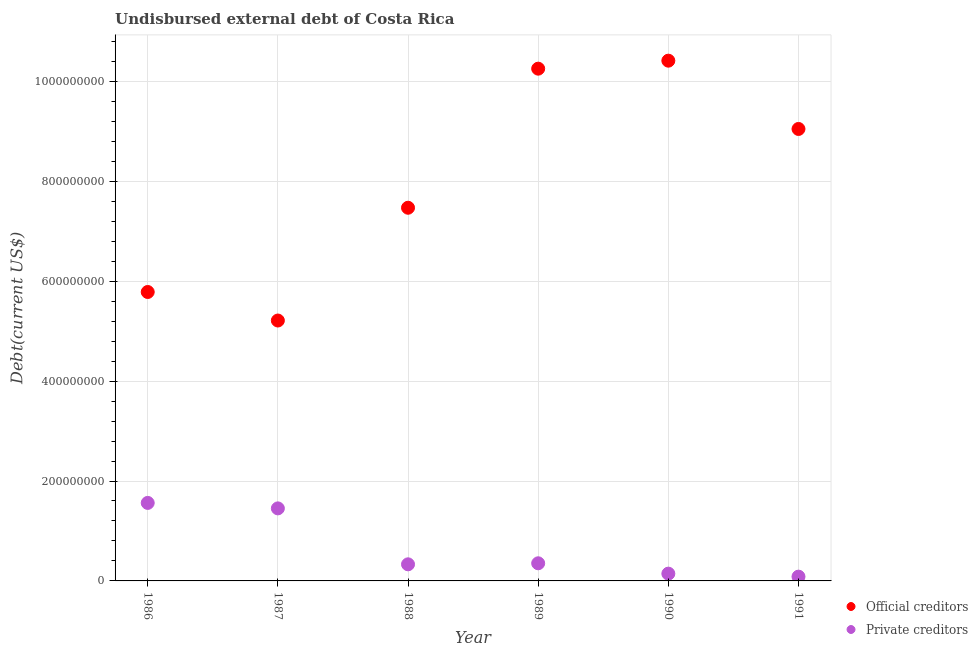What is the undisbursed external debt of private creditors in 1990?
Offer a very short reply. 1.46e+07. Across all years, what is the maximum undisbursed external debt of private creditors?
Make the answer very short. 1.56e+08. Across all years, what is the minimum undisbursed external debt of official creditors?
Ensure brevity in your answer.  5.21e+08. In which year was the undisbursed external debt of official creditors maximum?
Provide a succinct answer. 1990. In which year was the undisbursed external debt of private creditors minimum?
Offer a terse response. 1991. What is the total undisbursed external debt of official creditors in the graph?
Provide a succinct answer. 4.82e+09. What is the difference between the undisbursed external debt of official creditors in 1986 and that in 1987?
Your response must be concise. 5.71e+07. What is the difference between the undisbursed external debt of official creditors in 1990 and the undisbursed external debt of private creditors in 1988?
Provide a short and direct response. 1.01e+09. What is the average undisbursed external debt of private creditors per year?
Give a very brief answer. 6.55e+07. In the year 1989, what is the difference between the undisbursed external debt of private creditors and undisbursed external debt of official creditors?
Your answer should be compact. -9.90e+08. What is the ratio of the undisbursed external debt of private creditors in 1986 to that in 1991?
Provide a succinct answer. 18.25. Is the undisbursed external debt of official creditors in 1986 less than that in 1991?
Provide a short and direct response. Yes. Is the difference between the undisbursed external debt of official creditors in 1989 and 1991 greater than the difference between the undisbursed external debt of private creditors in 1989 and 1991?
Offer a very short reply. Yes. What is the difference between the highest and the second highest undisbursed external debt of official creditors?
Offer a terse response. 1.60e+07. What is the difference between the highest and the lowest undisbursed external debt of official creditors?
Offer a very short reply. 5.20e+08. Is the sum of the undisbursed external debt of official creditors in 1988 and 1990 greater than the maximum undisbursed external debt of private creditors across all years?
Your answer should be compact. Yes. Does the graph contain grids?
Keep it short and to the point. Yes. Where does the legend appear in the graph?
Offer a very short reply. Bottom right. How many legend labels are there?
Provide a succinct answer. 2. What is the title of the graph?
Ensure brevity in your answer.  Undisbursed external debt of Costa Rica. Does "Primary completion rate" appear as one of the legend labels in the graph?
Your response must be concise. No. What is the label or title of the X-axis?
Offer a very short reply. Year. What is the label or title of the Y-axis?
Your response must be concise. Debt(current US$). What is the Debt(current US$) in Official creditors in 1986?
Provide a short and direct response. 5.78e+08. What is the Debt(current US$) in Private creditors in 1986?
Provide a succinct answer. 1.56e+08. What is the Debt(current US$) of Official creditors in 1987?
Your response must be concise. 5.21e+08. What is the Debt(current US$) of Private creditors in 1987?
Offer a very short reply. 1.45e+08. What is the Debt(current US$) of Official creditors in 1988?
Your answer should be compact. 7.47e+08. What is the Debt(current US$) of Private creditors in 1988?
Ensure brevity in your answer.  3.32e+07. What is the Debt(current US$) in Official creditors in 1989?
Your response must be concise. 1.03e+09. What is the Debt(current US$) in Private creditors in 1989?
Keep it short and to the point. 3.53e+07. What is the Debt(current US$) of Official creditors in 1990?
Offer a terse response. 1.04e+09. What is the Debt(current US$) in Private creditors in 1990?
Ensure brevity in your answer.  1.46e+07. What is the Debt(current US$) of Official creditors in 1991?
Make the answer very short. 9.05e+08. What is the Debt(current US$) of Private creditors in 1991?
Ensure brevity in your answer.  8.56e+06. Across all years, what is the maximum Debt(current US$) of Official creditors?
Provide a short and direct response. 1.04e+09. Across all years, what is the maximum Debt(current US$) in Private creditors?
Provide a succinct answer. 1.56e+08. Across all years, what is the minimum Debt(current US$) in Official creditors?
Your response must be concise. 5.21e+08. Across all years, what is the minimum Debt(current US$) of Private creditors?
Your answer should be very brief. 8.56e+06. What is the total Debt(current US$) in Official creditors in the graph?
Your answer should be compact. 4.82e+09. What is the total Debt(current US$) in Private creditors in the graph?
Your answer should be compact. 3.93e+08. What is the difference between the Debt(current US$) in Official creditors in 1986 and that in 1987?
Ensure brevity in your answer.  5.71e+07. What is the difference between the Debt(current US$) of Private creditors in 1986 and that in 1987?
Your answer should be compact. 1.10e+07. What is the difference between the Debt(current US$) in Official creditors in 1986 and that in 1988?
Provide a short and direct response. -1.69e+08. What is the difference between the Debt(current US$) of Private creditors in 1986 and that in 1988?
Your answer should be very brief. 1.23e+08. What is the difference between the Debt(current US$) of Official creditors in 1986 and that in 1989?
Offer a terse response. -4.47e+08. What is the difference between the Debt(current US$) in Private creditors in 1986 and that in 1989?
Give a very brief answer. 1.21e+08. What is the difference between the Debt(current US$) in Official creditors in 1986 and that in 1990?
Your answer should be compact. -4.63e+08. What is the difference between the Debt(current US$) in Private creditors in 1986 and that in 1990?
Provide a succinct answer. 1.42e+08. What is the difference between the Debt(current US$) of Official creditors in 1986 and that in 1991?
Provide a short and direct response. -3.26e+08. What is the difference between the Debt(current US$) in Private creditors in 1986 and that in 1991?
Ensure brevity in your answer.  1.48e+08. What is the difference between the Debt(current US$) of Official creditors in 1987 and that in 1988?
Give a very brief answer. -2.26e+08. What is the difference between the Debt(current US$) of Private creditors in 1987 and that in 1988?
Give a very brief answer. 1.12e+08. What is the difference between the Debt(current US$) in Official creditors in 1987 and that in 1989?
Provide a succinct answer. -5.04e+08. What is the difference between the Debt(current US$) of Private creditors in 1987 and that in 1989?
Your answer should be very brief. 1.10e+08. What is the difference between the Debt(current US$) in Official creditors in 1987 and that in 1990?
Keep it short and to the point. -5.20e+08. What is the difference between the Debt(current US$) in Private creditors in 1987 and that in 1990?
Your answer should be compact. 1.31e+08. What is the difference between the Debt(current US$) in Official creditors in 1987 and that in 1991?
Your answer should be compact. -3.83e+08. What is the difference between the Debt(current US$) of Private creditors in 1987 and that in 1991?
Provide a succinct answer. 1.37e+08. What is the difference between the Debt(current US$) of Official creditors in 1988 and that in 1989?
Keep it short and to the point. -2.78e+08. What is the difference between the Debt(current US$) in Private creditors in 1988 and that in 1989?
Your answer should be very brief. -2.06e+06. What is the difference between the Debt(current US$) in Official creditors in 1988 and that in 1990?
Make the answer very short. -2.94e+08. What is the difference between the Debt(current US$) of Private creditors in 1988 and that in 1990?
Give a very brief answer. 1.87e+07. What is the difference between the Debt(current US$) of Official creditors in 1988 and that in 1991?
Offer a terse response. -1.58e+08. What is the difference between the Debt(current US$) of Private creditors in 1988 and that in 1991?
Provide a short and direct response. 2.47e+07. What is the difference between the Debt(current US$) in Official creditors in 1989 and that in 1990?
Your response must be concise. -1.60e+07. What is the difference between the Debt(current US$) in Private creditors in 1989 and that in 1990?
Make the answer very short. 2.07e+07. What is the difference between the Debt(current US$) in Official creditors in 1989 and that in 1991?
Your answer should be very brief. 1.21e+08. What is the difference between the Debt(current US$) in Private creditors in 1989 and that in 1991?
Offer a terse response. 2.67e+07. What is the difference between the Debt(current US$) of Official creditors in 1990 and that in 1991?
Provide a short and direct response. 1.37e+08. What is the difference between the Debt(current US$) in Private creditors in 1990 and that in 1991?
Offer a terse response. 6.01e+06. What is the difference between the Debt(current US$) of Official creditors in 1986 and the Debt(current US$) of Private creditors in 1987?
Offer a terse response. 4.33e+08. What is the difference between the Debt(current US$) in Official creditors in 1986 and the Debt(current US$) in Private creditors in 1988?
Your answer should be very brief. 5.45e+08. What is the difference between the Debt(current US$) in Official creditors in 1986 and the Debt(current US$) in Private creditors in 1989?
Give a very brief answer. 5.43e+08. What is the difference between the Debt(current US$) in Official creditors in 1986 and the Debt(current US$) in Private creditors in 1990?
Ensure brevity in your answer.  5.64e+08. What is the difference between the Debt(current US$) in Official creditors in 1986 and the Debt(current US$) in Private creditors in 1991?
Your answer should be compact. 5.70e+08. What is the difference between the Debt(current US$) of Official creditors in 1987 and the Debt(current US$) of Private creditors in 1988?
Offer a terse response. 4.88e+08. What is the difference between the Debt(current US$) of Official creditors in 1987 and the Debt(current US$) of Private creditors in 1989?
Your answer should be very brief. 4.86e+08. What is the difference between the Debt(current US$) of Official creditors in 1987 and the Debt(current US$) of Private creditors in 1990?
Keep it short and to the point. 5.07e+08. What is the difference between the Debt(current US$) of Official creditors in 1987 and the Debt(current US$) of Private creditors in 1991?
Give a very brief answer. 5.13e+08. What is the difference between the Debt(current US$) in Official creditors in 1988 and the Debt(current US$) in Private creditors in 1989?
Ensure brevity in your answer.  7.12e+08. What is the difference between the Debt(current US$) in Official creditors in 1988 and the Debt(current US$) in Private creditors in 1990?
Keep it short and to the point. 7.32e+08. What is the difference between the Debt(current US$) of Official creditors in 1988 and the Debt(current US$) of Private creditors in 1991?
Provide a succinct answer. 7.38e+08. What is the difference between the Debt(current US$) in Official creditors in 1989 and the Debt(current US$) in Private creditors in 1990?
Your answer should be compact. 1.01e+09. What is the difference between the Debt(current US$) of Official creditors in 1989 and the Debt(current US$) of Private creditors in 1991?
Your answer should be compact. 1.02e+09. What is the difference between the Debt(current US$) in Official creditors in 1990 and the Debt(current US$) in Private creditors in 1991?
Provide a succinct answer. 1.03e+09. What is the average Debt(current US$) in Official creditors per year?
Make the answer very short. 8.03e+08. What is the average Debt(current US$) in Private creditors per year?
Keep it short and to the point. 6.55e+07. In the year 1986, what is the difference between the Debt(current US$) in Official creditors and Debt(current US$) in Private creditors?
Offer a terse response. 4.22e+08. In the year 1987, what is the difference between the Debt(current US$) in Official creditors and Debt(current US$) in Private creditors?
Offer a terse response. 3.76e+08. In the year 1988, what is the difference between the Debt(current US$) in Official creditors and Debt(current US$) in Private creditors?
Offer a very short reply. 7.14e+08. In the year 1989, what is the difference between the Debt(current US$) of Official creditors and Debt(current US$) of Private creditors?
Keep it short and to the point. 9.90e+08. In the year 1990, what is the difference between the Debt(current US$) in Official creditors and Debt(current US$) in Private creditors?
Offer a very short reply. 1.03e+09. In the year 1991, what is the difference between the Debt(current US$) of Official creditors and Debt(current US$) of Private creditors?
Your answer should be very brief. 8.96e+08. What is the ratio of the Debt(current US$) in Official creditors in 1986 to that in 1987?
Provide a succinct answer. 1.11. What is the ratio of the Debt(current US$) in Private creditors in 1986 to that in 1987?
Ensure brevity in your answer.  1.08. What is the ratio of the Debt(current US$) of Official creditors in 1986 to that in 1988?
Provide a succinct answer. 0.77. What is the ratio of the Debt(current US$) of Private creditors in 1986 to that in 1988?
Your answer should be very brief. 4.7. What is the ratio of the Debt(current US$) in Official creditors in 1986 to that in 1989?
Ensure brevity in your answer.  0.56. What is the ratio of the Debt(current US$) in Private creditors in 1986 to that in 1989?
Offer a terse response. 4.42. What is the ratio of the Debt(current US$) of Official creditors in 1986 to that in 1990?
Make the answer very short. 0.56. What is the ratio of the Debt(current US$) of Private creditors in 1986 to that in 1990?
Make the answer very short. 10.72. What is the ratio of the Debt(current US$) in Official creditors in 1986 to that in 1991?
Your response must be concise. 0.64. What is the ratio of the Debt(current US$) of Private creditors in 1986 to that in 1991?
Your response must be concise. 18.25. What is the ratio of the Debt(current US$) in Official creditors in 1987 to that in 1988?
Your response must be concise. 0.7. What is the ratio of the Debt(current US$) in Private creditors in 1987 to that in 1988?
Make the answer very short. 4.37. What is the ratio of the Debt(current US$) of Official creditors in 1987 to that in 1989?
Your response must be concise. 0.51. What is the ratio of the Debt(current US$) of Private creditors in 1987 to that in 1989?
Provide a succinct answer. 4.11. What is the ratio of the Debt(current US$) in Official creditors in 1987 to that in 1990?
Offer a terse response. 0.5. What is the ratio of the Debt(current US$) in Private creditors in 1987 to that in 1990?
Provide a short and direct response. 9.97. What is the ratio of the Debt(current US$) in Official creditors in 1987 to that in 1991?
Make the answer very short. 0.58. What is the ratio of the Debt(current US$) in Private creditors in 1987 to that in 1991?
Give a very brief answer. 16.97. What is the ratio of the Debt(current US$) in Official creditors in 1988 to that in 1989?
Offer a terse response. 0.73. What is the ratio of the Debt(current US$) of Private creditors in 1988 to that in 1989?
Provide a succinct answer. 0.94. What is the ratio of the Debt(current US$) in Official creditors in 1988 to that in 1990?
Give a very brief answer. 0.72. What is the ratio of the Debt(current US$) of Private creditors in 1988 to that in 1990?
Offer a terse response. 2.28. What is the ratio of the Debt(current US$) of Official creditors in 1988 to that in 1991?
Make the answer very short. 0.83. What is the ratio of the Debt(current US$) of Private creditors in 1988 to that in 1991?
Offer a very short reply. 3.88. What is the ratio of the Debt(current US$) in Official creditors in 1989 to that in 1990?
Ensure brevity in your answer.  0.98. What is the ratio of the Debt(current US$) of Private creditors in 1989 to that in 1990?
Your response must be concise. 2.42. What is the ratio of the Debt(current US$) of Official creditors in 1989 to that in 1991?
Your response must be concise. 1.13. What is the ratio of the Debt(current US$) in Private creditors in 1989 to that in 1991?
Offer a terse response. 4.12. What is the ratio of the Debt(current US$) of Official creditors in 1990 to that in 1991?
Offer a very short reply. 1.15. What is the ratio of the Debt(current US$) of Private creditors in 1990 to that in 1991?
Make the answer very short. 1.7. What is the difference between the highest and the second highest Debt(current US$) of Official creditors?
Offer a terse response. 1.60e+07. What is the difference between the highest and the second highest Debt(current US$) of Private creditors?
Provide a short and direct response. 1.10e+07. What is the difference between the highest and the lowest Debt(current US$) of Official creditors?
Offer a very short reply. 5.20e+08. What is the difference between the highest and the lowest Debt(current US$) of Private creditors?
Your response must be concise. 1.48e+08. 